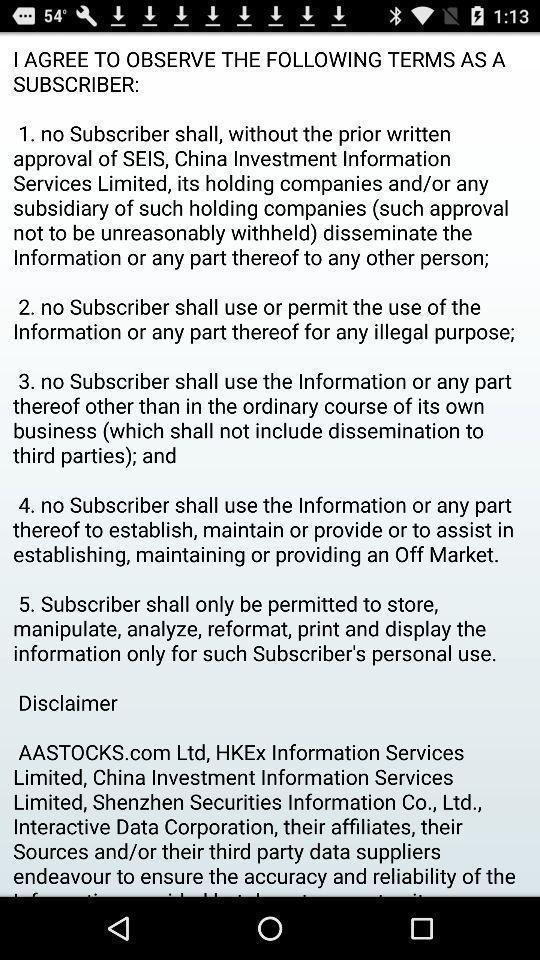Provide a detailed account of this screenshot. Page displaying with information about the application. 